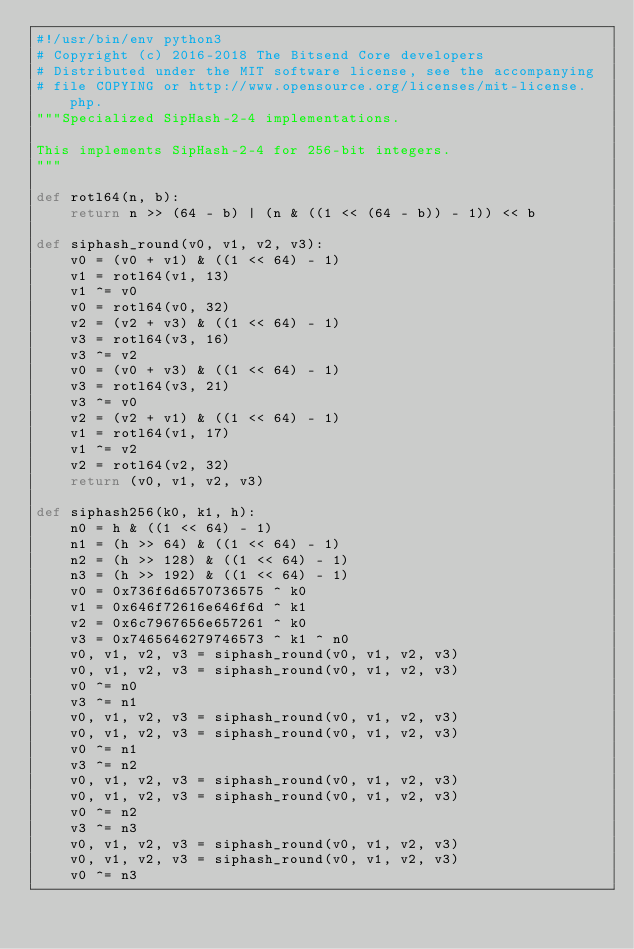Convert code to text. <code><loc_0><loc_0><loc_500><loc_500><_Python_>#!/usr/bin/env python3
# Copyright (c) 2016-2018 The Bitsend Core developers
# Distributed under the MIT software license, see the accompanying
# file COPYING or http://www.opensource.org/licenses/mit-license.php.
"""Specialized SipHash-2-4 implementations.

This implements SipHash-2-4 for 256-bit integers.
"""

def rotl64(n, b):
    return n >> (64 - b) | (n & ((1 << (64 - b)) - 1)) << b

def siphash_round(v0, v1, v2, v3):
    v0 = (v0 + v1) & ((1 << 64) - 1)
    v1 = rotl64(v1, 13)
    v1 ^= v0
    v0 = rotl64(v0, 32)
    v2 = (v2 + v3) & ((1 << 64) - 1)
    v3 = rotl64(v3, 16)
    v3 ^= v2
    v0 = (v0 + v3) & ((1 << 64) - 1)
    v3 = rotl64(v3, 21)
    v3 ^= v0
    v2 = (v2 + v1) & ((1 << 64) - 1)
    v1 = rotl64(v1, 17)
    v1 ^= v2
    v2 = rotl64(v2, 32)
    return (v0, v1, v2, v3)

def siphash256(k0, k1, h):
    n0 = h & ((1 << 64) - 1)
    n1 = (h >> 64) & ((1 << 64) - 1)
    n2 = (h >> 128) & ((1 << 64) - 1)
    n3 = (h >> 192) & ((1 << 64) - 1)
    v0 = 0x736f6d6570736575 ^ k0
    v1 = 0x646f72616e646f6d ^ k1
    v2 = 0x6c7967656e657261 ^ k0
    v3 = 0x7465646279746573 ^ k1 ^ n0
    v0, v1, v2, v3 = siphash_round(v0, v1, v2, v3)
    v0, v1, v2, v3 = siphash_round(v0, v1, v2, v3)
    v0 ^= n0
    v3 ^= n1
    v0, v1, v2, v3 = siphash_round(v0, v1, v2, v3)
    v0, v1, v2, v3 = siphash_round(v0, v1, v2, v3)
    v0 ^= n1
    v3 ^= n2
    v0, v1, v2, v3 = siphash_round(v0, v1, v2, v3)
    v0, v1, v2, v3 = siphash_round(v0, v1, v2, v3)
    v0 ^= n2
    v3 ^= n3
    v0, v1, v2, v3 = siphash_round(v0, v1, v2, v3)
    v0, v1, v2, v3 = siphash_round(v0, v1, v2, v3)
    v0 ^= n3</code> 